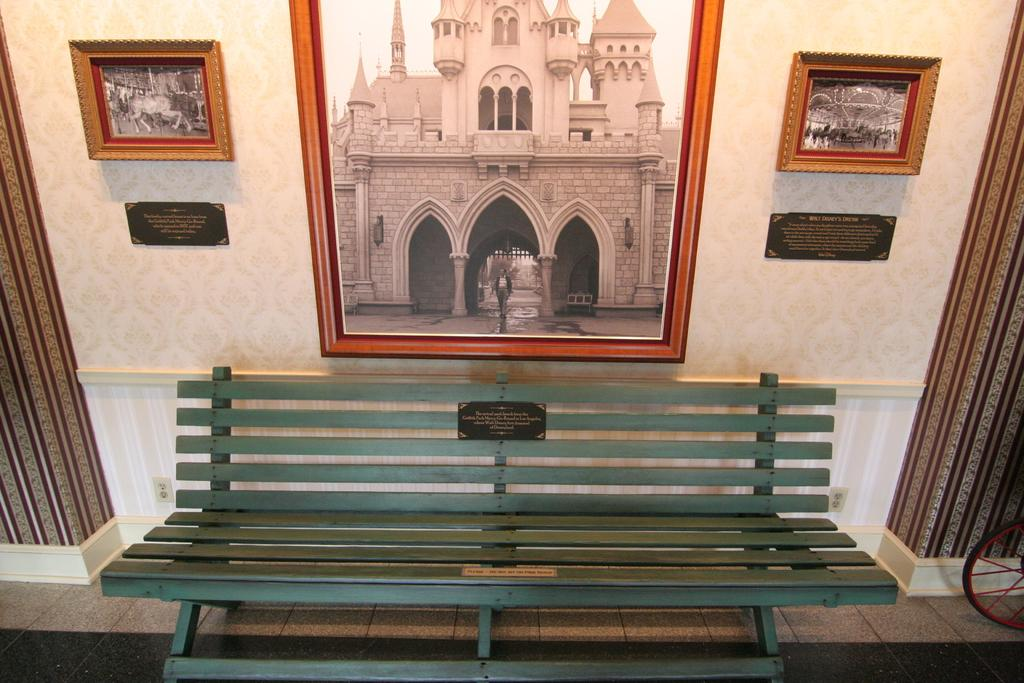What is placed on the floor in the image? There is a bench placed on the floor. What can be seen attached to the wall at the top of the image? There are photo frames attached to the wall at the top of the image. What type of window treatment is present on the right side of the image? There are curtains on the right side of the image. What type of window treatment is present on the left side of the image? There are curtains on the left side of the image. How many times does the person in the image jump over the rake? There is no person or rake present in the image. What message of peace is conveyed in the image? There is no message of peace conveyed in the image; it features a bench, photo frames, and curtains. 